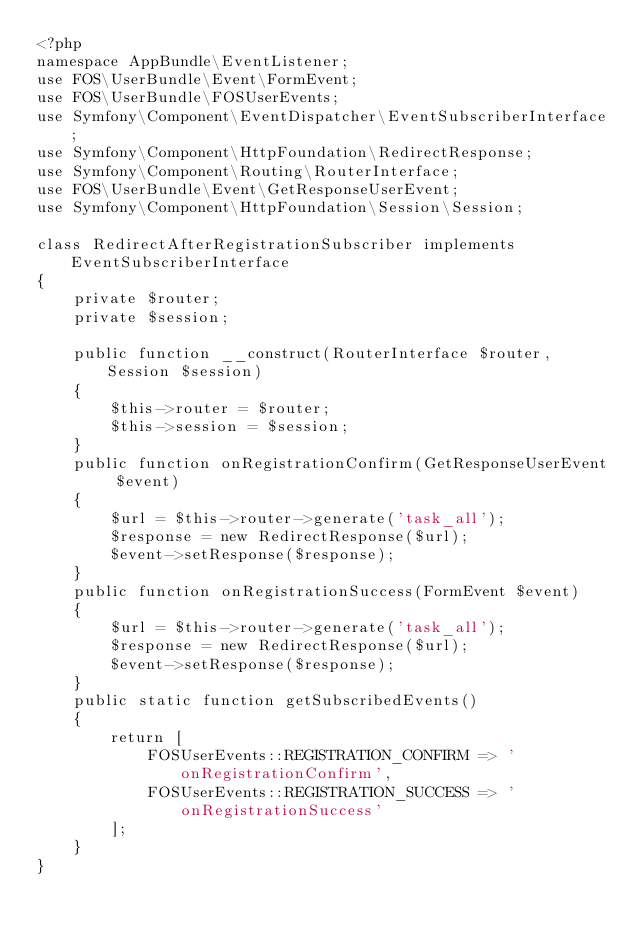Convert code to text. <code><loc_0><loc_0><loc_500><loc_500><_PHP_><?php
namespace AppBundle\EventListener;
use FOS\UserBundle\Event\FormEvent;
use FOS\UserBundle\FOSUserEvents;
use Symfony\Component\EventDispatcher\EventSubscriberInterface;
use Symfony\Component\HttpFoundation\RedirectResponse;
use Symfony\Component\Routing\RouterInterface;
use FOS\UserBundle\Event\GetResponseUserEvent;
use Symfony\Component\HttpFoundation\Session\Session;

class RedirectAfterRegistrationSubscriber implements EventSubscriberInterface
{
    private $router;
    private $session;

    public function __construct(RouterInterface $router, Session $session)
    {
        $this->router = $router;
        $this->session = $session;
    }
    public function onRegistrationConfirm(GetResponseUserEvent $event)
    {
        $url = $this->router->generate('task_all');
        $response = new RedirectResponse($url);
        $event->setResponse($response);
    }
    public function onRegistrationSuccess(FormEvent $event)
    {
        $url = $this->router->generate('task_all');
        $response = new RedirectResponse($url);
        $event->setResponse($response);
    }
    public static function getSubscribedEvents()
    {
        return [
            FOSUserEvents::REGISTRATION_CONFIRM => 'onRegistrationConfirm',
            FOSUserEvents::REGISTRATION_SUCCESS => 'onRegistrationSuccess'
        ];
    }
}</code> 